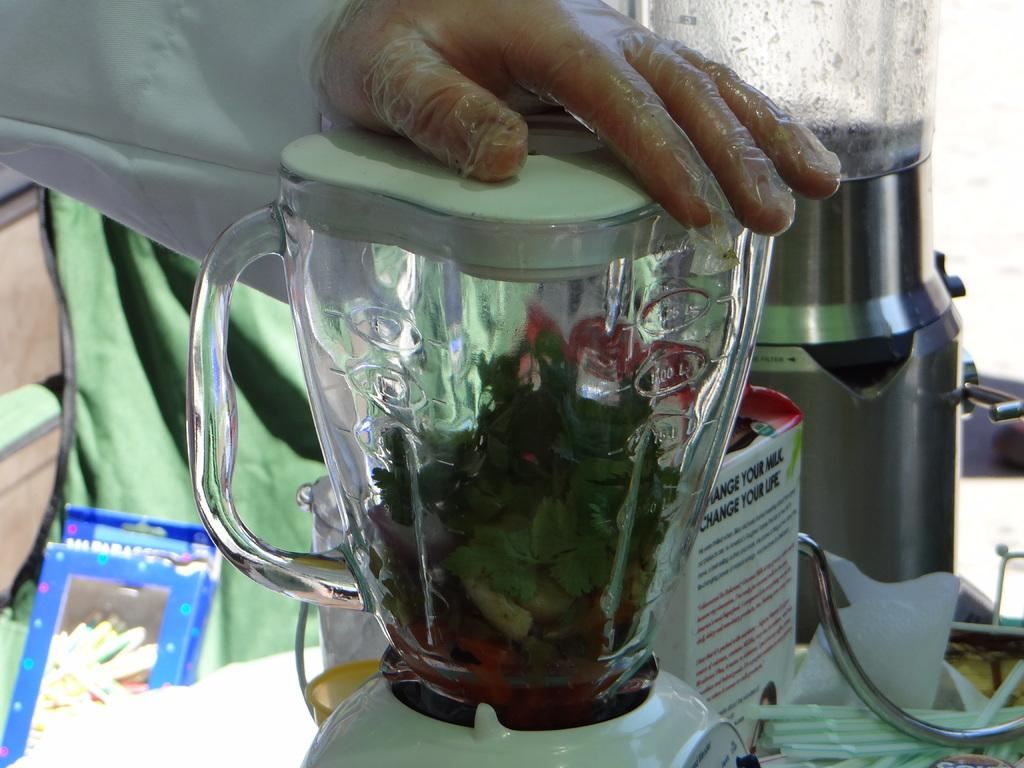<image>
Describe the image concisely. A carton can be seen behind a blender with the words change your life on it. 